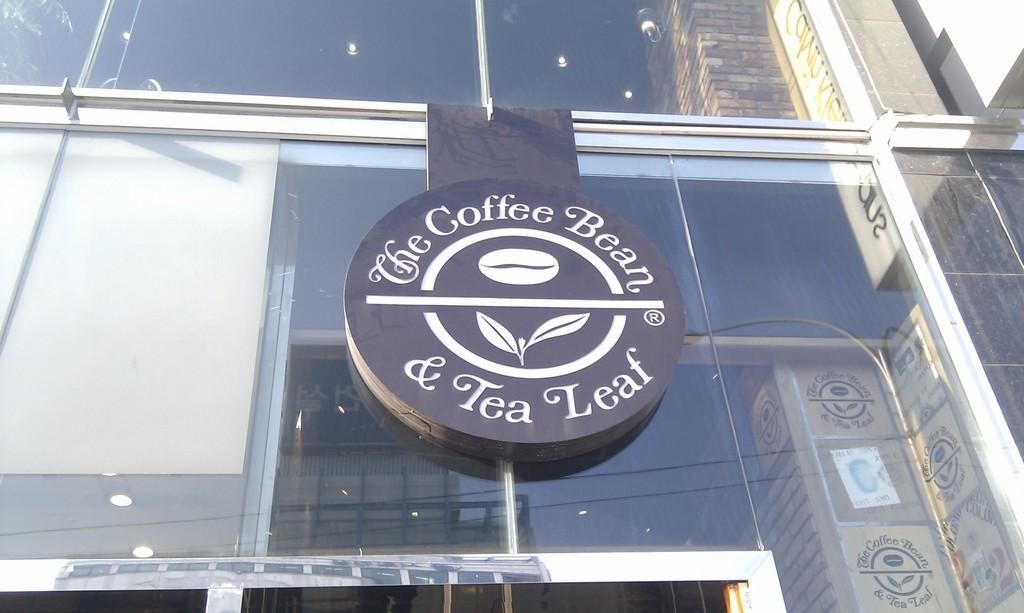What type of structure is visible in the image? There is a building in the image. What feature can be seen on the building? The building has a glass wall. What is displayed on the glass wall? There is a logo and some text on the glass wall. Are there any bushes burning near the building in the image? There is no mention of bushes or fire in the image, so it cannot be determined if any bushes are burning. 